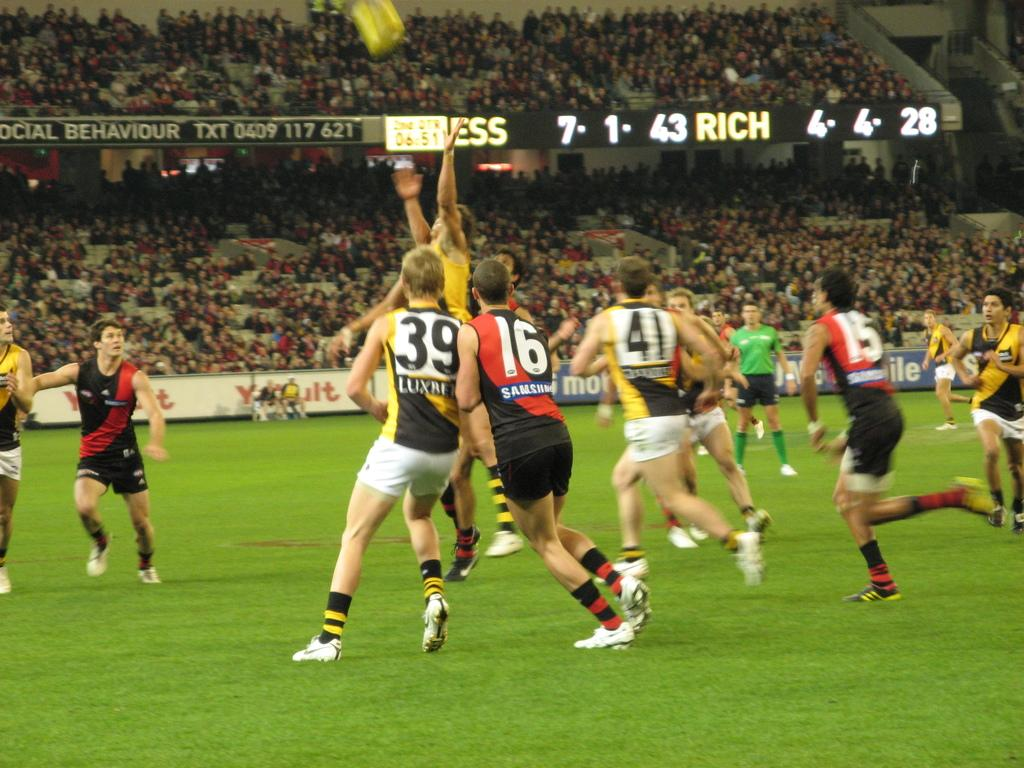<image>
Offer a succinct explanation of the picture presented. a soccer field with a scoreboard that says 'rich' on it 